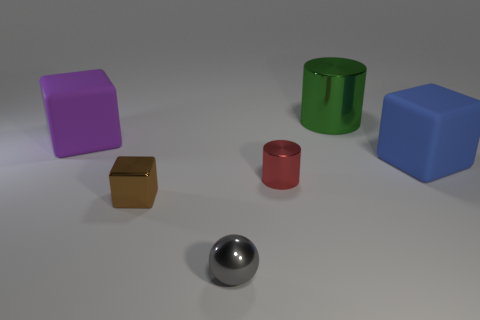Subtract all large cubes. How many cubes are left? 1 Add 2 brown metal objects. How many objects exist? 8 Subtract 2 cubes. How many cubes are left? 1 Subtract all purple cubes. How many cubes are left? 2 Subtract all cylinders. How many objects are left? 4 Subtract all yellow spheres. Subtract all green cylinders. How many spheres are left? 1 Subtract all yellow cubes. How many red cylinders are left? 1 Subtract all small gray balls. Subtract all cylinders. How many objects are left? 3 Add 2 large blue things. How many large blue things are left? 3 Add 3 big blue rubber objects. How many big blue rubber objects exist? 4 